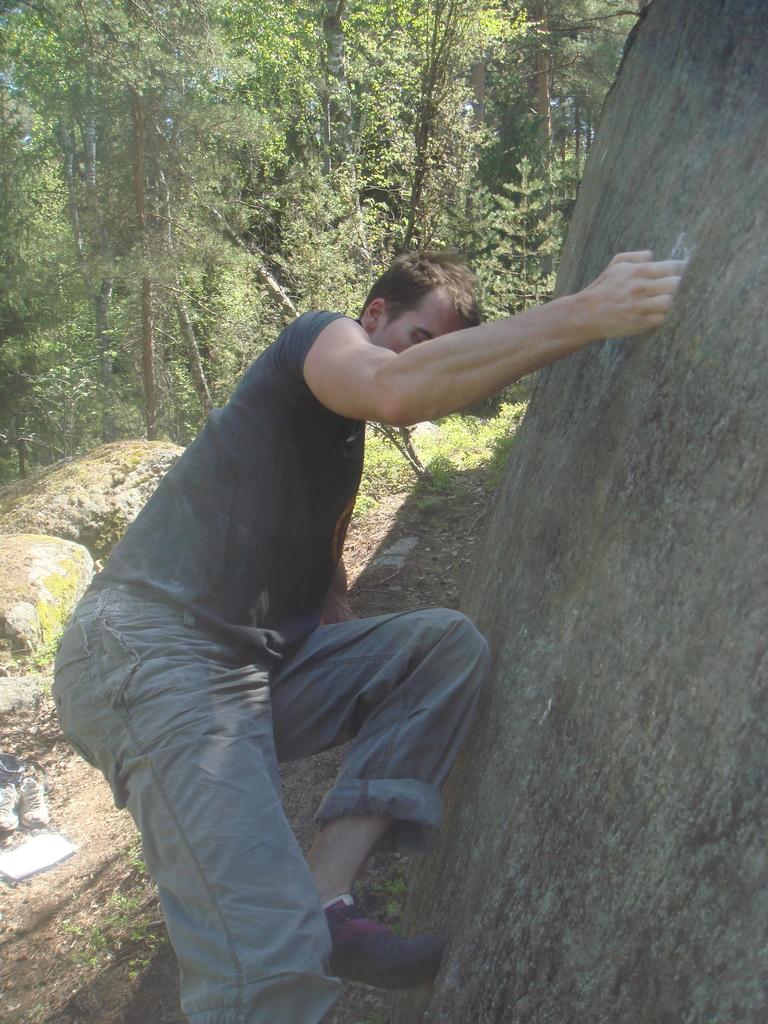Can you describe this image briefly? In this image we can see a person climbing the hill. We can also see the rocks, a pair of shoes, book, grass and also the trees. 